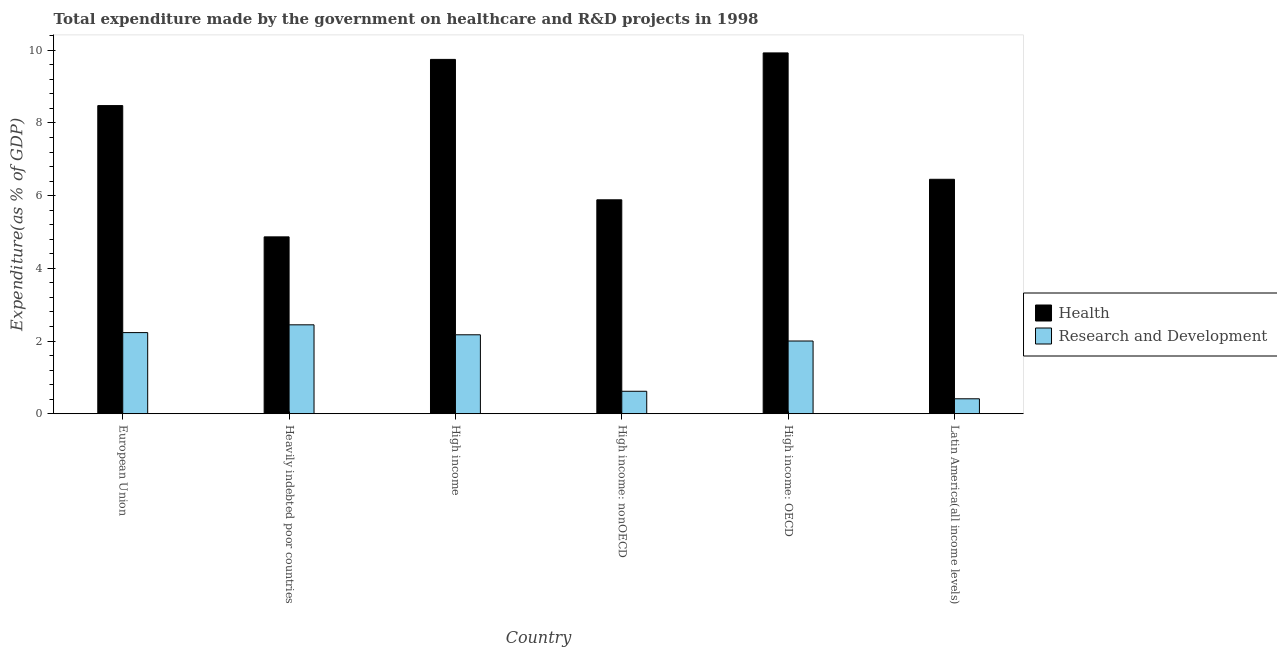Are the number of bars per tick equal to the number of legend labels?
Ensure brevity in your answer.  Yes. In how many cases, is the number of bars for a given country not equal to the number of legend labels?
Your answer should be compact. 0. What is the expenditure in healthcare in Latin America(all income levels)?
Your answer should be very brief. 6.45. Across all countries, what is the maximum expenditure in r&d?
Your response must be concise. 2.45. Across all countries, what is the minimum expenditure in r&d?
Provide a short and direct response. 0.41. In which country was the expenditure in r&d maximum?
Your response must be concise. Heavily indebted poor countries. In which country was the expenditure in healthcare minimum?
Offer a terse response. Heavily indebted poor countries. What is the total expenditure in r&d in the graph?
Your answer should be compact. 9.88. What is the difference between the expenditure in r&d in Heavily indebted poor countries and that in High income?
Keep it short and to the point. 0.27. What is the difference between the expenditure in healthcare in Latin America(all income levels) and the expenditure in r&d in High income: nonOECD?
Your response must be concise. 5.83. What is the average expenditure in healthcare per country?
Give a very brief answer. 7.56. What is the difference between the expenditure in healthcare and expenditure in r&d in High income: nonOECD?
Your answer should be very brief. 5.27. What is the ratio of the expenditure in r&d in Heavily indebted poor countries to that in High income?
Offer a very short reply. 1.13. Is the difference between the expenditure in r&d in European Union and High income greater than the difference between the expenditure in healthcare in European Union and High income?
Your answer should be compact. Yes. What is the difference between the highest and the second highest expenditure in r&d?
Keep it short and to the point. 0.21. What is the difference between the highest and the lowest expenditure in r&d?
Offer a terse response. 2.03. In how many countries, is the expenditure in healthcare greater than the average expenditure in healthcare taken over all countries?
Give a very brief answer. 3. Is the sum of the expenditure in r&d in European Union and Latin America(all income levels) greater than the maximum expenditure in healthcare across all countries?
Offer a terse response. No. What does the 2nd bar from the left in High income: OECD represents?
Keep it short and to the point. Research and Development. What does the 1st bar from the right in High income: OECD represents?
Your answer should be compact. Research and Development. How many bars are there?
Provide a short and direct response. 12. Are all the bars in the graph horizontal?
Make the answer very short. No. How many countries are there in the graph?
Offer a very short reply. 6. What is the difference between two consecutive major ticks on the Y-axis?
Ensure brevity in your answer.  2. Does the graph contain grids?
Provide a succinct answer. No. Where does the legend appear in the graph?
Ensure brevity in your answer.  Center right. How many legend labels are there?
Make the answer very short. 2. What is the title of the graph?
Give a very brief answer. Total expenditure made by the government on healthcare and R&D projects in 1998. What is the label or title of the Y-axis?
Offer a very short reply. Expenditure(as % of GDP). What is the Expenditure(as % of GDP) in Health in European Union?
Ensure brevity in your answer.  8.48. What is the Expenditure(as % of GDP) in Research and Development in European Union?
Provide a short and direct response. 2.23. What is the Expenditure(as % of GDP) in Health in Heavily indebted poor countries?
Keep it short and to the point. 4.87. What is the Expenditure(as % of GDP) of Research and Development in Heavily indebted poor countries?
Offer a very short reply. 2.45. What is the Expenditure(as % of GDP) of Health in High income?
Give a very brief answer. 9.75. What is the Expenditure(as % of GDP) in Research and Development in High income?
Your answer should be compact. 2.17. What is the Expenditure(as % of GDP) of Health in High income: nonOECD?
Provide a short and direct response. 5.88. What is the Expenditure(as % of GDP) of Research and Development in High income: nonOECD?
Make the answer very short. 0.62. What is the Expenditure(as % of GDP) of Health in High income: OECD?
Your answer should be compact. 9.93. What is the Expenditure(as % of GDP) of Research and Development in High income: OECD?
Make the answer very short. 2. What is the Expenditure(as % of GDP) in Health in Latin America(all income levels)?
Provide a short and direct response. 6.45. What is the Expenditure(as % of GDP) in Research and Development in Latin America(all income levels)?
Give a very brief answer. 0.41. Across all countries, what is the maximum Expenditure(as % of GDP) of Health?
Give a very brief answer. 9.93. Across all countries, what is the maximum Expenditure(as % of GDP) of Research and Development?
Offer a very short reply. 2.45. Across all countries, what is the minimum Expenditure(as % of GDP) in Health?
Offer a terse response. 4.87. Across all countries, what is the minimum Expenditure(as % of GDP) of Research and Development?
Keep it short and to the point. 0.41. What is the total Expenditure(as % of GDP) in Health in the graph?
Provide a short and direct response. 45.35. What is the total Expenditure(as % of GDP) of Research and Development in the graph?
Offer a very short reply. 9.88. What is the difference between the Expenditure(as % of GDP) of Health in European Union and that in Heavily indebted poor countries?
Make the answer very short. 3.61. What is the difference between the Expenditure(as % of GDP) of Research and Development in European Union and that in Heavily indebted poor countries?
Make the answer very short. -0.21. What is the difference between the Expenditure(as % of GDP) in Health in European Union and that in High income?
Keep it short and to the point. -1.27. What is the difference between the Expenditure(as % of GDP) in Research and Development in European Union and that in High income?
Offer a terse response. 0.06. What is the difference between the Expenditure(as % of GDP) of Health in European Union and that in High income: nonOECD?
Ensure brevity in your answer.  2.59. What is the difference between the Expenditure(as % of GDP) in Research and Development in European Union and that in High income: nonOECD?
Your response must be concise. 1.61. What is the difference between the Expenditure(as % of GDP) in Health in European Union and that in High income: OECD?
Make the answer very short. -1.45. What is the difference between the Expenditure(as % of GDP) of Research and Development in European Union and that in High income: OECD?
Your answer should be compact. 0.23. What is the difference between the Expenditure(as % of GDP) of Health in European Union and that in Latin America(all income levels)?
Your answer should be compact. 2.03. What is the difference between the Expenditure(as % of GDP) in Research and Development in European Union and that in Latin America(all income levels)?
Your answer should be very brief. 1.82. What is the difference between the Expenditure(as % of GDP) in Health in Heavily indebted poor countries and that in High income?
Give a very brief answer. -4.88. What is the difference between the Expenditure(as % of GDP) of Research and Development in Heavily indebted poor countries and that in High income?
Your response must be concise. 0.27. What is the difference between the Expenditure(as % of GDP) of Health in Heavily indebted poor countries and that in High income: nonOECD?
Offer a terse response. -1.02. What is the difference between the Expenditure(as % of GDP) in Research and Development in Heavily indebted poor countries and that in High income: nonOECD?
Your answer should be compact. 1.83. What is the difference between the Expenditure(as % of GDP) of Health in Heavily indebted poor countries and that in High income: OECD?
Your response must be concise. -5.06. What is the difference between the Expenditure(as % of GDP) of Research and Development in Heavily indebted poor countries and that in High income: OECD?
Provide a succinct answer. 0.45. What is the difference between the Expenditure(as % of GDP) of Health in Heavily indebted poor countries and that in Latin America(all income levels)?
Keep it short and to the point. -1.58. What is the difference between the Expenditure(as % of GDP) of Research and Development in Heavily indebted poor countries and that in Latin America(all income levels)?
Your answer should be very brief. 2.03. What is the difference between the Expenditure(as % of GDP) in Health in High income and that in High income: nonOECD?
Keep it short and to the point. 3.86. What is the difference between the Expenditure(as % of GDP) in Research and Development in High income and that in High income: nonOECD?
Provide a short and direct response. 1.55. What is the difference between the Expenditure(as % of GDP) of Health in High income and that in High income: OECD?
Provide a succinct answer. -0.18. What is the difference between the Expenditure(as % of GDP) in Research and Development in High income and that in High income: OECD?
Provide a succinct answer. 0.17. What is the difference between the Expenditure(as % of GDP) in Health in High income and that in Latin America(all income levels)?
Your answer should be compact. 3.3. What is the difference between the Expenditure(as % of GDP) of Research and Development in High income and that in Latin America(all income levels)?
Offer a terse response. 1.76. What is the difference between the Expenditure(as % of GDP) in Health in High income: nonOECD and that in High income: OECD?
Ensure brevity in your answer.  -4.04. What is the difference between the Expenditure(as % of GDP) in Research and Development in High income: nonOECD and that in High income: OECD?
Your answer should be very brief. -1.38. What is the difference between the Expenditure(as % of GDP) in Health in High income: nonOECD and that in Latin America(all income levels)?
Provide a succinct answer. -0.56. What is the difference between the Expenditure(as % of GDP) of Research and Development in High income: nonOECD and that in Latin America(all income levels)?
Make the answer very short. 0.21. What is the difference between the Expenditure(as % of GDP) of Health in High income: OECD and that in Latin America(all income levels)?
Your answer should be compact. 3.48. What is the difference between the Expenditure(as % of GDP) of Research and Development in High income: OECD and that in Latin America(all income levels)?
Offer a very short reply. 1.59. What is the difference between the Expenditure(as % of GDP) of Health in European Union and the Expenditure(as % of GDP) of Research and Development in Heavily indebted poor countries?
Make the answer very short. 6.03. What is the difference between the Expenditure(as % of GDP) of Health in European Union and the Expenditure(as % of GDP) of Research and Development in High income?
Offer a terse response. 6.31. What is the difference between the Expenditure(as % of GDP) of Health in European Union and the Expenditure(as % of GDP) of Research and Development in High income: nonOECD?
Your answer should be very brief. 7.86. What is the difference between the Expenditure(as % of GDP) of Health in European Union and the Expenditure(as % of GDP) of Research and Development in High income: OECD?
Your response must be concise. 6.48. What is the difference between the Expenditure(as % of GDP) in Health in European Union and the Expenditure(as % of GDP) in Research and Development in Latin America(all income levels)?
Give a very brief answer. 8.07. What is the difference between the Expenditure(as % of GDP) in Health in Heavily indebted poor countries and the Expenditure(as % of GDP) in Research and Development in High income?
Keep it short and to the point. 2.69. What is the difference between the Expenditure(as % of GDP) in Health in Heavily indebted poor countries and the Expenditure(as % of GDP) in Research and Development in High income: nonOECD?
Your answer should be very brief. 4.25. What is the difference between the Expenditure(as % of GDP) in Health in Heavily indebted poor countries and the Expenditure(as % of GDP) in Research and Development in High income: OECD?
Your response must be concise. 2.86. What is the difference between the Expenditure(as % of GDP) in Health in Heavily indebted poor countries and the Expenditure(as % of GDP) in Research and Development in Latin America(all income levels)?
Provide a short and direct response. 4.45. What is the difference between the Expenditure(as % of GDP) in Health in High income and the Expenditure(as % of GDP) in Research and Development in High income: nonOECD?
Offer a terse response. 9.13. What is the difference between the Expenditure(as % of GDP) in Health in High income and the Expenditure(as % of GDP) in Research and Development in High income: OECD?
Make the answer very short. 7.75. What is the difference between the Expenditure(as % of GDP) in Health in High income and the Expenditure(as % of GDP) in Research and Development in Latin America(all income levels)?
Ensure brevity in your answer.  9.34. What is the difference between the Expenditure(as % of GDP) of Health in High income: nonOECD and the Expenditure(as % of GDP) of Research and Development in High income: OECD?
Provide a short and direct response. 3.88. What is the difference between the Expenditure(as % of GDP) in Health in High income: nonOECD and the Expenditure(as % of GDP) in Research and Development in Latin America(all income levels)?
Provide a short and direct response. 5.47. What is the difference between the Expenditure(as % of GDP) of Health in High income: OECD and the Expenditure(as % of GDP) of Research and Development in Latin America(all income levels)?
Your answer should be compact. 9.51. What is the average Expenditure(as % of GDP) in Health per country?
Your answer should be very brief. 7.56. What is the average Expenditure(as % of GDP) in Research and Development per country?
Your answer should be compact. 1.65. What is the difference between the Expenditure(as % of GDP) of Health and Expenditure(as % of GDP) of Research and Development in European Union?
Offer a very short reply. 6.24. What is the difference between the Expenditure(as % of GDP) of Health and Expenditure(as % of GDP) of Research and Development in Heavily indebted poor countries?
Your answer should be very brief. 2.42. What is the difference between the Expenditure(as % of GDP) in Health and Expenditure(as % of GDP) in Research and Development in High income?
Offer a very short reply. 7.58. What is the difference between the Expenditure(as % of GDP) of Health and Expenditure(as % of GDP) of Research and Development in High income: nonOECD?
Your answer should be compact. 5.27. What is the difference between the Expenditure(as % of GDP) in Health and Expenditure(as % of GDP) in Research and Development in High income: OECD?
Your response must be concise. 7.93. What is the difference between the Expenditure(as % of GDP) in Health and Expenditure(as % of GDP) in Research and Development in Latin America(all income levels)?
Make the answer very short. 6.04. What is the ratio of the Expenditure(as % of GDP) of Health in European Union to that in Heavily indebted poor countries?
Your answer should be compact. 1.74. What is the ratio of the Expenditure(as % of GDP) in Research and Development in European Union to that in Heavily indebted poor countries?
Your response must be concise. 0.91. What is the ratio of the Expenditure(as % of GDP) of Health in European Union to that in High income?
Provide a succinct answer. 0.87. What is the ratio of the Expenditure(as % of GDP) in Research and Development in European Union to that in High income?
Your answer should be compact. 1.03. What is the ratio of the Expenditure(as % of GDP) in Health in European Union to that in High income: nonOECD?
Keep it short and to the point. 1.44. What is the ratio of the Expenditure(as % of GDP) in Research and Development in European Union to that in High income: nonOECD?
Give a very brief answer. 3.61. What is the ratio of the Expenditure(as % of GDP) in Health in European Union to that in High income: OECD?
Your answer should be compact. 0.85. What is the ratio of the Expenditure(as % of GDP) of Research and Development in European Union to that in High income: OECD?
Give a very brief answer. 1.12. What is the ratio of the Expenditure(as % of GDP) of Health in European Union to that in Latin America(all income levels)?
Ensure brevity in your answer.  1.31. What is the ratio of the Expenditure(as % of GDP) in Research and Development in European Union to that in Latin America(all income levels)?
Offer a very short reply. 5.43. What is the ratio of the Expenditure(as % of GDP) of Health in Heavily indebted poor countries to that in High income?
Offer a terse response. 0.5. What is the ratio of the Expenditure(as % of GDP) of Research and Development in Heavily indebted poor countries to that in High income?
Your answer should be very brief. 1.13. What is the ratio of the Expenditure(as % of GDP) in Health in Heavily indebted poor countries to that in High income: nonOECD?
Keep it short and to the point. 0.83. What is the ratio of the Expenditure(as % of GDP) of Research and Development in Heavily indebted poor countries to that in High income: nonOECD?
Your answer should be very brief. 3.96. What is the ratio of the Expenditure(as % of GDP) in Health in Heavily indebted poor countries to that in High income: OECD?
Offer a very short reply. 0.49. What is the ratio of the Expenditure(as % of GDP) of Research and Development in Heavily indebted poor countries to that in High income: OECD?
Offer a terse response. 1.22. What is the ratio of the Expenditure(as % of GDP) in Health in Heavily indebted poor countries to that in Latin America(all income levels)?
Make the answer very short. 0.75. What is the ratio of the Expenditure(as % of GDP) of Research and Development in Heavily indebted poor countries to that in Latin America(all income levels)?
Give a very brief answer. 5.95. What is the ratio of the Expenditure(as % of GDP) in Health in High income to that in High income: nonOECD?
Offer a very short reply. 1.66. What is the ratio of the Expenditure(as % of GDP) of Research and Development in High income to that in High income: nonOECD?
Give a very brief answer. 3.52. What is the ratio of the Expenditure(as % of GDP) of Health in High income to that in High income: OECD?
Give a very brief answer. 0.98. What is the ratio of the Expenditure(as % of GDP) in Research and Development in High income to that in High income: OECD?
Keep it short and to the point. 1.09. What is the ratio of the Expenditure(as % of GDP) in Health in High income to that in Latin America(all income levels)?
Your response must be concise. 1.51. What is the ratio of the Expenditure(as % of GDP) in Research and Development in High income to that in Latin America(all income levels)?
Your answer should be compact. 5.28. What is the ratio of the Expenditure(as % of GDP) of Health in High income: nonOECD to that in High income: OECD?
Offer a very short reply. 0.59. What is the ratio of the Expenditure(as % of GDP) of Research and Development in High income: nonOECD to that in High income: OECD?
Provide a succinct answer. 0.31. What is the ratio of the Expenditure(as % of GDP) of Health in High income: nonOECD to that in Latin America(all income levels)?
Offer a terse response. 0.91. What is the ratio of the Expenditure(as % of GDP) of Research and Development in High income: nonOECD to that in Latin America(all income levels)?
Provide a short and direct response. 1.5. What is the ratio of the Expenditure(as % of GDP) of Health in High income: OECD to that in Latin America(all income levels)?
Provide a short and direct response. 1.54. What is the ratio of the Expenditure(as % of GDP) in Research and Development in High income: OECD to that in Latin America(all income levels)?
Offer a very short reply. 4.86. What is the difference between the highest and the second highest Expenditure(as % of GDP) of Health?
Your answer should be compact. 0.18. What is the difference between the highest and the second highest Expenditure(as % of GDP) in Research and Development?
Provide a short and direct response. 0.21. What is the difference between the highest and the lowest Expenditure(as % of GDP) in Health?
Your answer should be very brief. 5.06. What is the difference between the highest and the lowest Expenditure(as % of GDP) of Research and Development?
Offer a terse response. 2.03. 